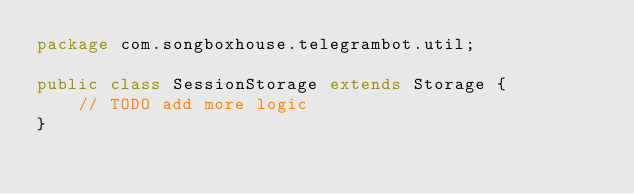Convert code to text. <code><loc_0><loc_0><loc_500><loc_500><_Java_>package com.songboxhouse.telegrambot.util;

public class SessionStorage extends Storage {
    // TODO add more logic
}
</code> 